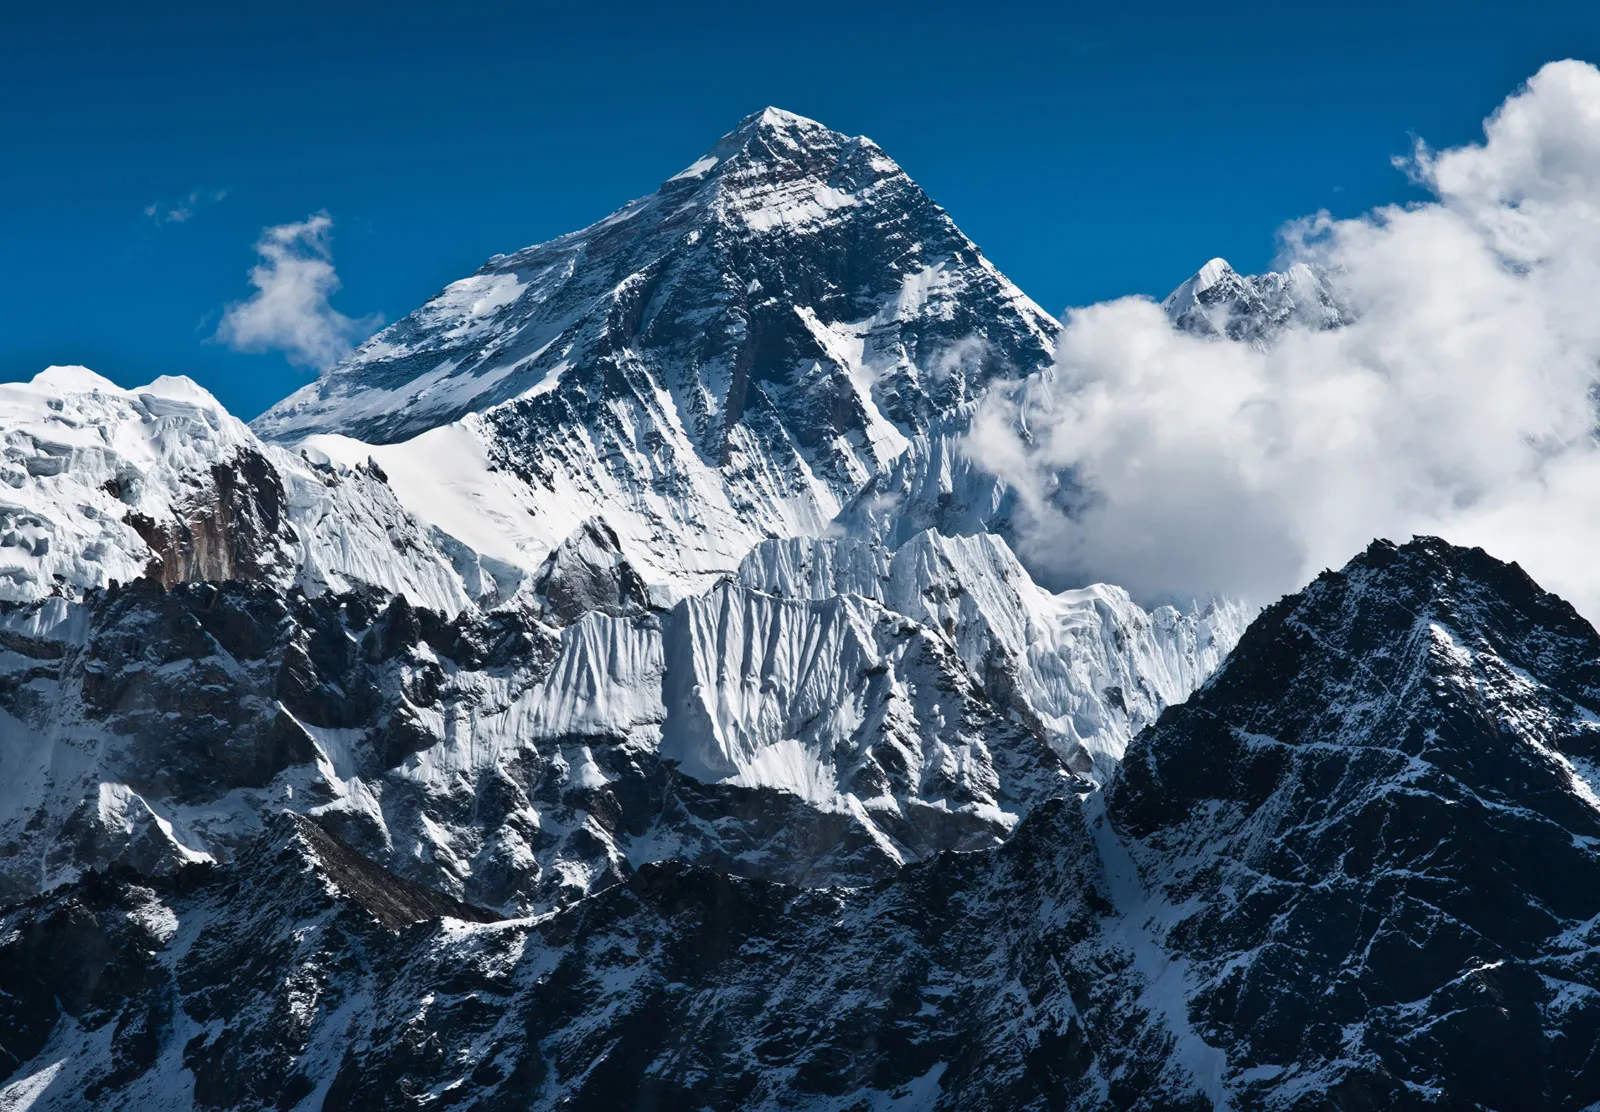Imagine preparing for a day's journey around the base of Mount Everest. What are some things you would expect to see and experience? Preparing for a day's journey around the base of Mount Everest brings anticipation and excitement. Expect to see the sun's first light painting the peaks with a golden hue. You’ll experience the biting cold air that invigorates your senses as you step out. Along the journey, you'll encounter fellow trekkers and the warm smiles of Sherpas guiding expeditions. Sounds of prayer bells and chants from nearby monasteries fill the atmosphere, offering a spiritual essence to the adventure. As you trek, the scenery changes from dense forests to vast, rocky plains, each step rewarding you with majestic views of the towering Everest and the surrounding ranges. 